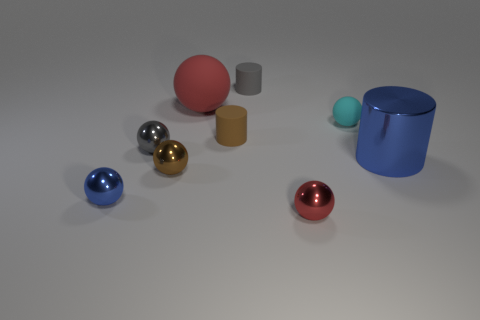What color is the tiny object that is on the right side of the small blue metal object and to the left of the small brown shiny thing?
Your response must be concise. Gray. What number of tiny red things are to the left of the tiny blue metal sphere?
Ensure brevity in your answer.  0. What is the material of the cyan thing?
Offer a very short reply. Rubber. What is the color of the cylinder that is behind the red ball that is left of the tiny cylinder right of the brown cylinder?
Keep it short and to the point. Gray. What number of red spheres have the same size as the blue cylinder?
Your response must be concise. 1. What color is the big object that is to the left of the small gray cylinder?
Ensure brevity in your answer.  Red. How many other things are the same size as the gray metallic thing?
Your answer should be very brief. 6. How big is the thing that is on the right side of the tiny red sphere and behind the metal cylinder?
Your answer should be very brief. Small. There is a large cylinder; is its color the same as the metal object to the left of the gray ball?
Make the answer very short. Yes. Is there a small green object that has the same shape as the brown metal object?
Provide a succinct answer. No. 